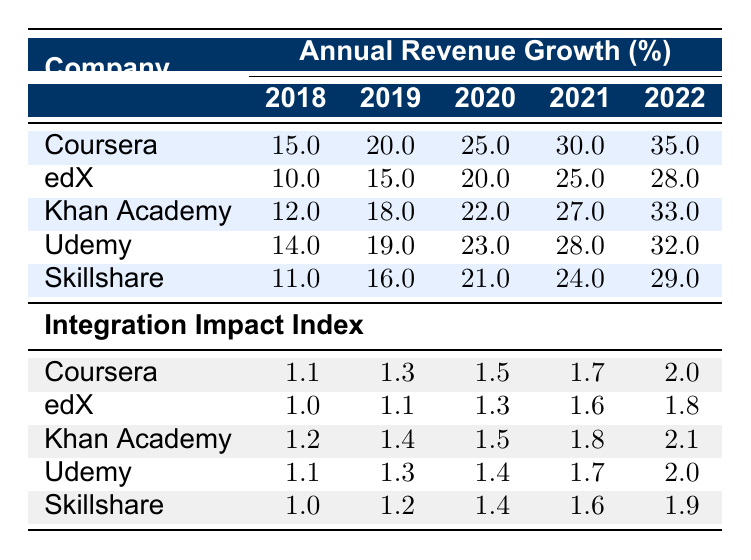What was the revenue growth percentage of Coursera in 2020? The table indicates that the revenue growth percentage for Coursera in 2020 is listed under the corresponding year, which shows a value of 25.0.
Answer: 25.0 Which company had the highest revenue growth in 2022? In the year 2022, looking at the revenue growth percentages for all companies, Coursera has the highest value at 35.0, compared to others.
Answer: Coursera What is the average revenue growth for Khan Academy from 2018 to 2022? To find the average, add the revenue growth percentages for Khan Academy from 2018 (12.0), 2019 (18.0), 2020 (22.0), 2021 (27.0), and 2022 (33.0), which equals 112.0. Then divide by 5 (the number of years), resulting in 112.0 / 5 = 22.4.
Answer: 22.4 Did Skillshare show an increase in revenue growth from 2019 to 2020? By comparing the revenue growth percentages of Skillshare in 2019 (16.0) and 2020 (21.0), it is clear that the value increased from 16.0 to 21.0, thus confirming an increase.
Answer: Yes What is the total revenue growth percentage for all companies combined in 2021? To find the total for 2021, add the revenue growth percentages for all companies: Coursera (30.0) + edX (25.0) + Khan Academy (27.0) + Udemy (28.0) + Skillshare (24.0), resulting in a total of 134.0.
Answer: 134.0 How much did the revenue growth of Udemy increase from 2018 to 2022? The revenue growth for Udemy in 2018 is 14.0, and in 2022 it is 32.0. The increase is calculated as 32.0 - 14.0 = 18.0.
Answer: 18.0 Which company had a higher integration impact index in 2022, Khan Academy or edX? The integration impact index for Khan Academy in 2022 is 2.1, while for edX it is 1.8. Since 2.1 is greater than 1.8, Khan Academy had the higher index.
Answer: Khan Academy Was there a decline in revenue growth for any company between 2021 and 2022? By reviewing the revenue growth percentages from 2021 (30.0 for Coursera, 25.0 for edX, 27.0 for Khan Academy, 28.0 for Udemy, 24.0 for Skillshare) and 2022 (35.0 for Coursera, 28.0 for edX, 33.0 for Khan Academy, 32.0 for Udemy, 29.0 for Skillshare), there was no decline; all values increased or stayed the same.
Answer: No What is the highest integration impact index observed for any company in 2022? In 2022, the integration impact index for Coursera is 2.0, Khan Academy is 2.1, Udemy is 2.0, and Skillshare is 1.9. The highest value here is 2.1 for Khan Academy.
Answer: 2.1 